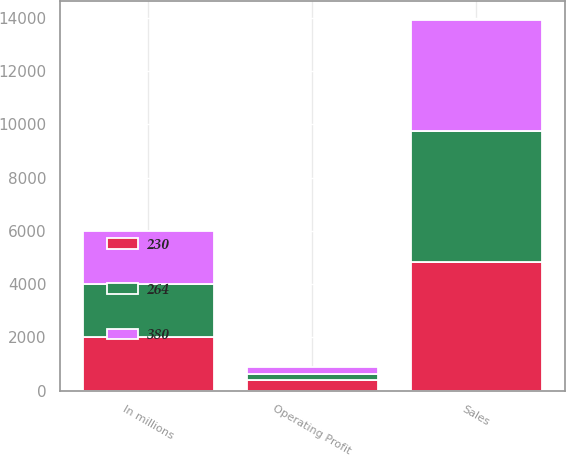Convert chart. <chart><loc_0><loc_0><loc_500><loc_500><stacked_bar_chart><ecel><fcel>In millions<fcel>Sales<fcel>Operating Profit<nl><fcel>264<fcel>2005<fcel>4935<fcel>230<nl><fcel>230<fcel>2004<fcel>4830<fcel>380<nl><fcel>380<fcel>2003<fcel>4170<fcel>264<nl></chart> 